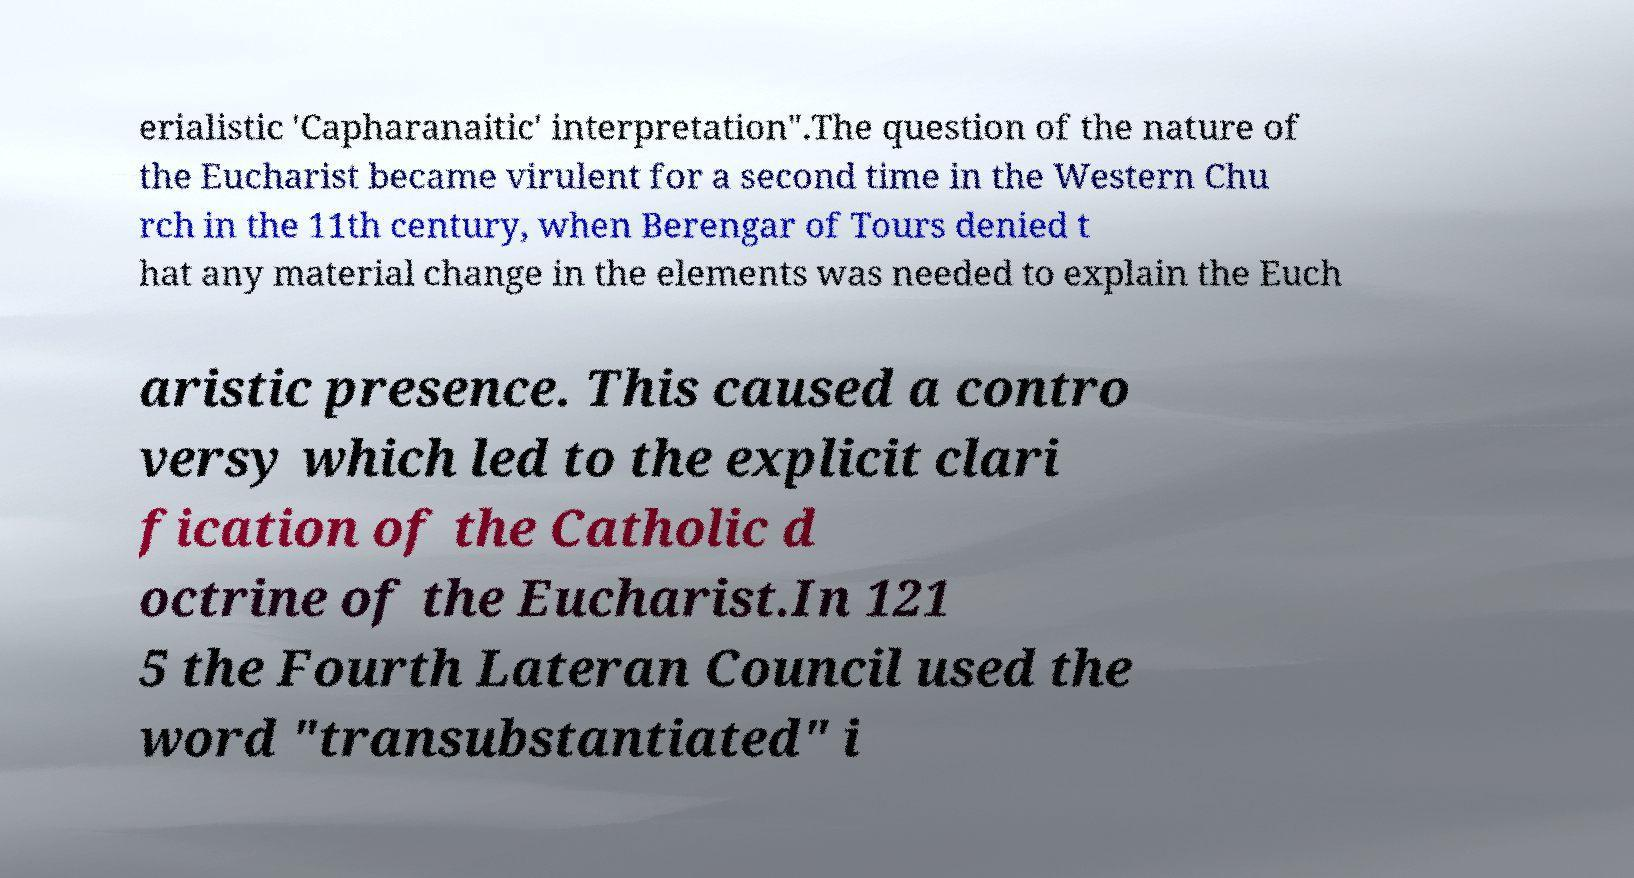For documentation purposes, I need the text within this image transcribed. Could you provide that? erialistic 'Capharanaitic' interpretation".The question of the nature of the Eucharist became virulent for a second time in the Western Chu rch in the 11th century, when Berengar of Tours denied t hat any material change in the elements was needed to explain the Euch aristic presence. This caused a contro versy which led to the explicit clari fication of the Catholic d octrine of the Eucharist.In 121 5 the Fourth Lateran Council used the word "transubstantiated" i 